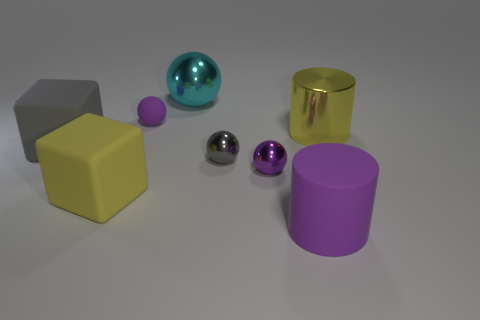What number of objects are cyan shiny objects or small rubber blocks?
Your answer should be very brief. 1. What number of shiny objects are in front of the big gray thing that is left of the big rubber object to the right of the cyan sphere?
Your response must be concise. 2. There is another object that is the same shape as the yellow rubber object; what is it made of?
Provide a succinct answer. Rubber. There is a purple object that is both on the left side of the large purple object and in front of the gray block; what is its material?
Your answer should be compact. Metal. Is the number of yellow blocks in front of the large ball less than the number of big objects to the left of the small purple matte object?
Provide a short and direct response. Yes. How many other objects are there of the same size as the gray rubber thing?
Your answer should be compact. 4. What shape is the small purple thing that is behind the gray thing that is left of the purple ball that is behind the big metal cylinder?
Your answer should be compact. Sphere. How many brown things are small matte balls or big metal objects?
Ensure brevity in your answer.  0. How many shiny balls are behind the purple thing left of the large sphere?
Ensure brevity in your answer.  1. Is there anything else of the same color as the big matte cylinder?
Your answer should be compact. Yes. 